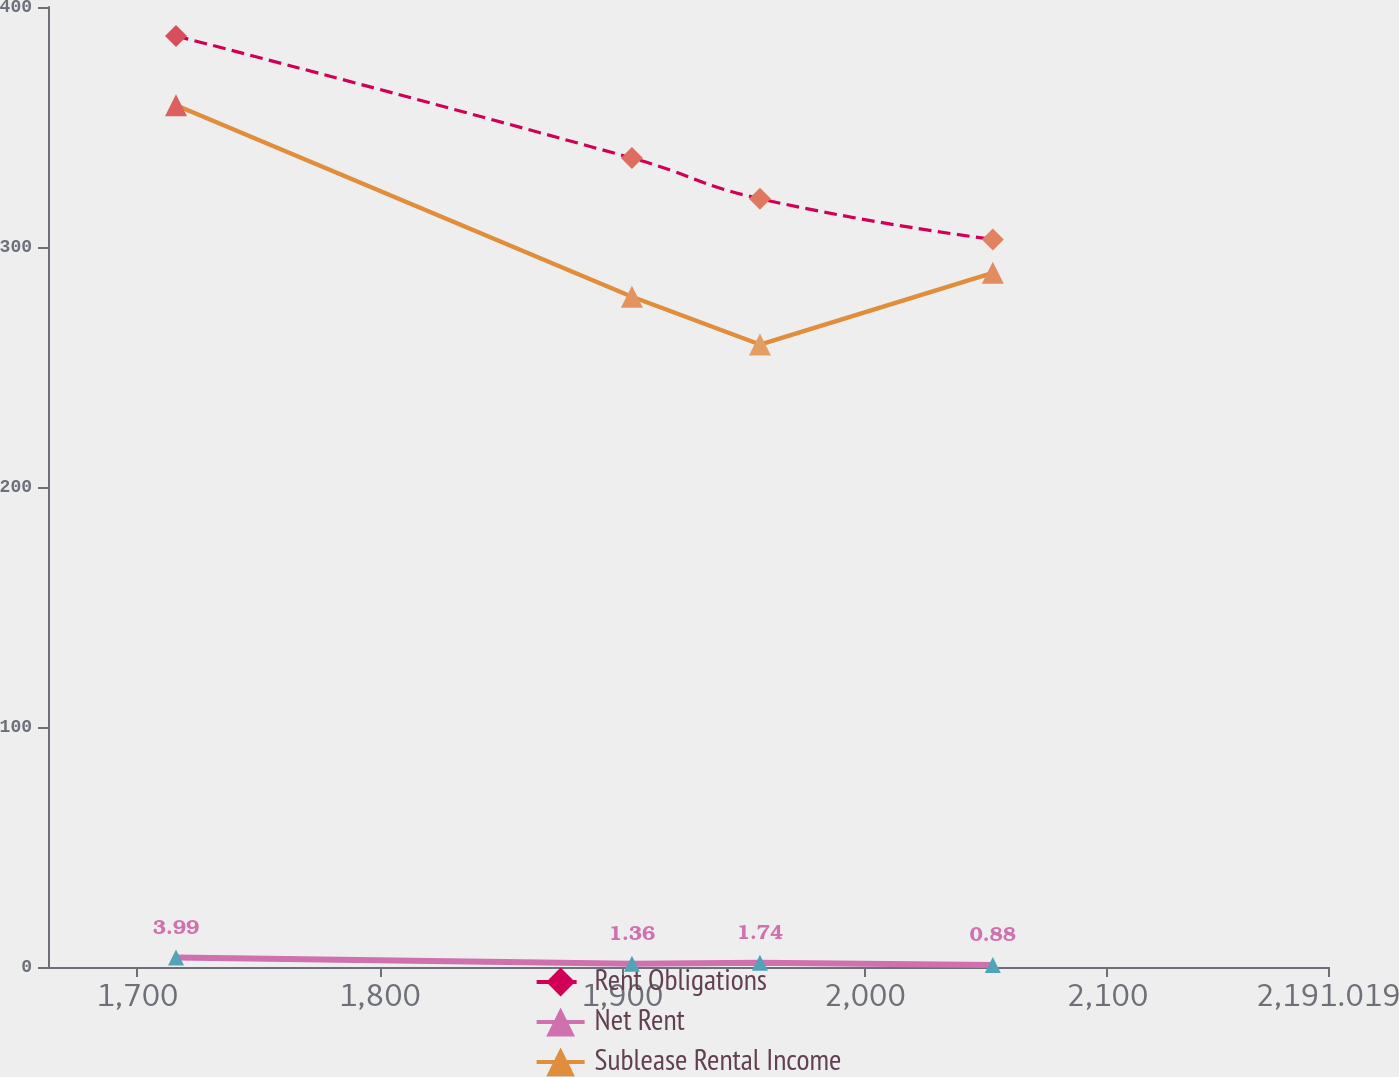Convert chart to OTSL. <chart><loc_0><loc_0><loc_500><loc_500><line_chart><ecel><fcel>Rent Obligations<fcel>Net Rent<fcel>Sublease Rental Income<nl><fcel>1715.9<fcel>387.94<fcel>3.99<fcel>359.06<nl><fcel>1903.95<fcel>337.05<fcel>1.36<fcel>279.29<nl><fcel>1956.74<fcel>320.11<fcel>1.74<fcel>259.35<nl><fcel>2052.77<fcel>303.17<fcel>0.88<fcel>289.26<nl><fcel>2243.81<fcel>218.53<fcel>0.21<fcel>269.32<nl></chart> 